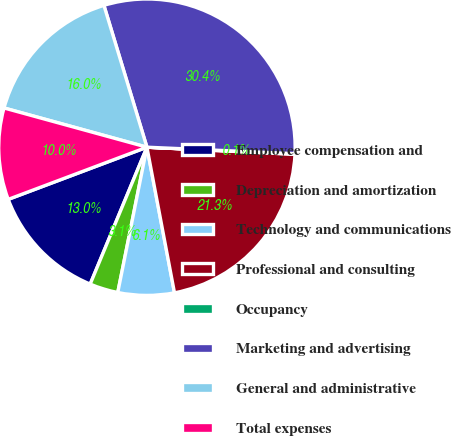Convert chart. <chart><loc_0><loc_0><loc_500><loc_500><pie_chart><fcel>Employee compensation and<fcel>Depreciation and amortization<fcel>Technology and communications<fcel>Professional and consulting<fcel>Occupancy<fcel>Marketing and advertising<fcel>General and administrative<fcel>Total expenses<nl><fcel>13.02%<fcel>3.1%<fcel>6.13%<fcel>21.26%<fcel>0.07%<fcel>30.38%<fcel>16.05%<fcel>9.99%<nl></chart> 